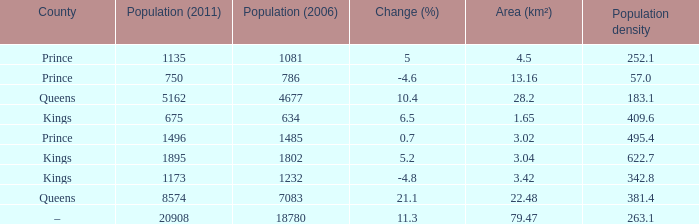What was the 2011 population count when the 2006 population count was less than 0.0. 